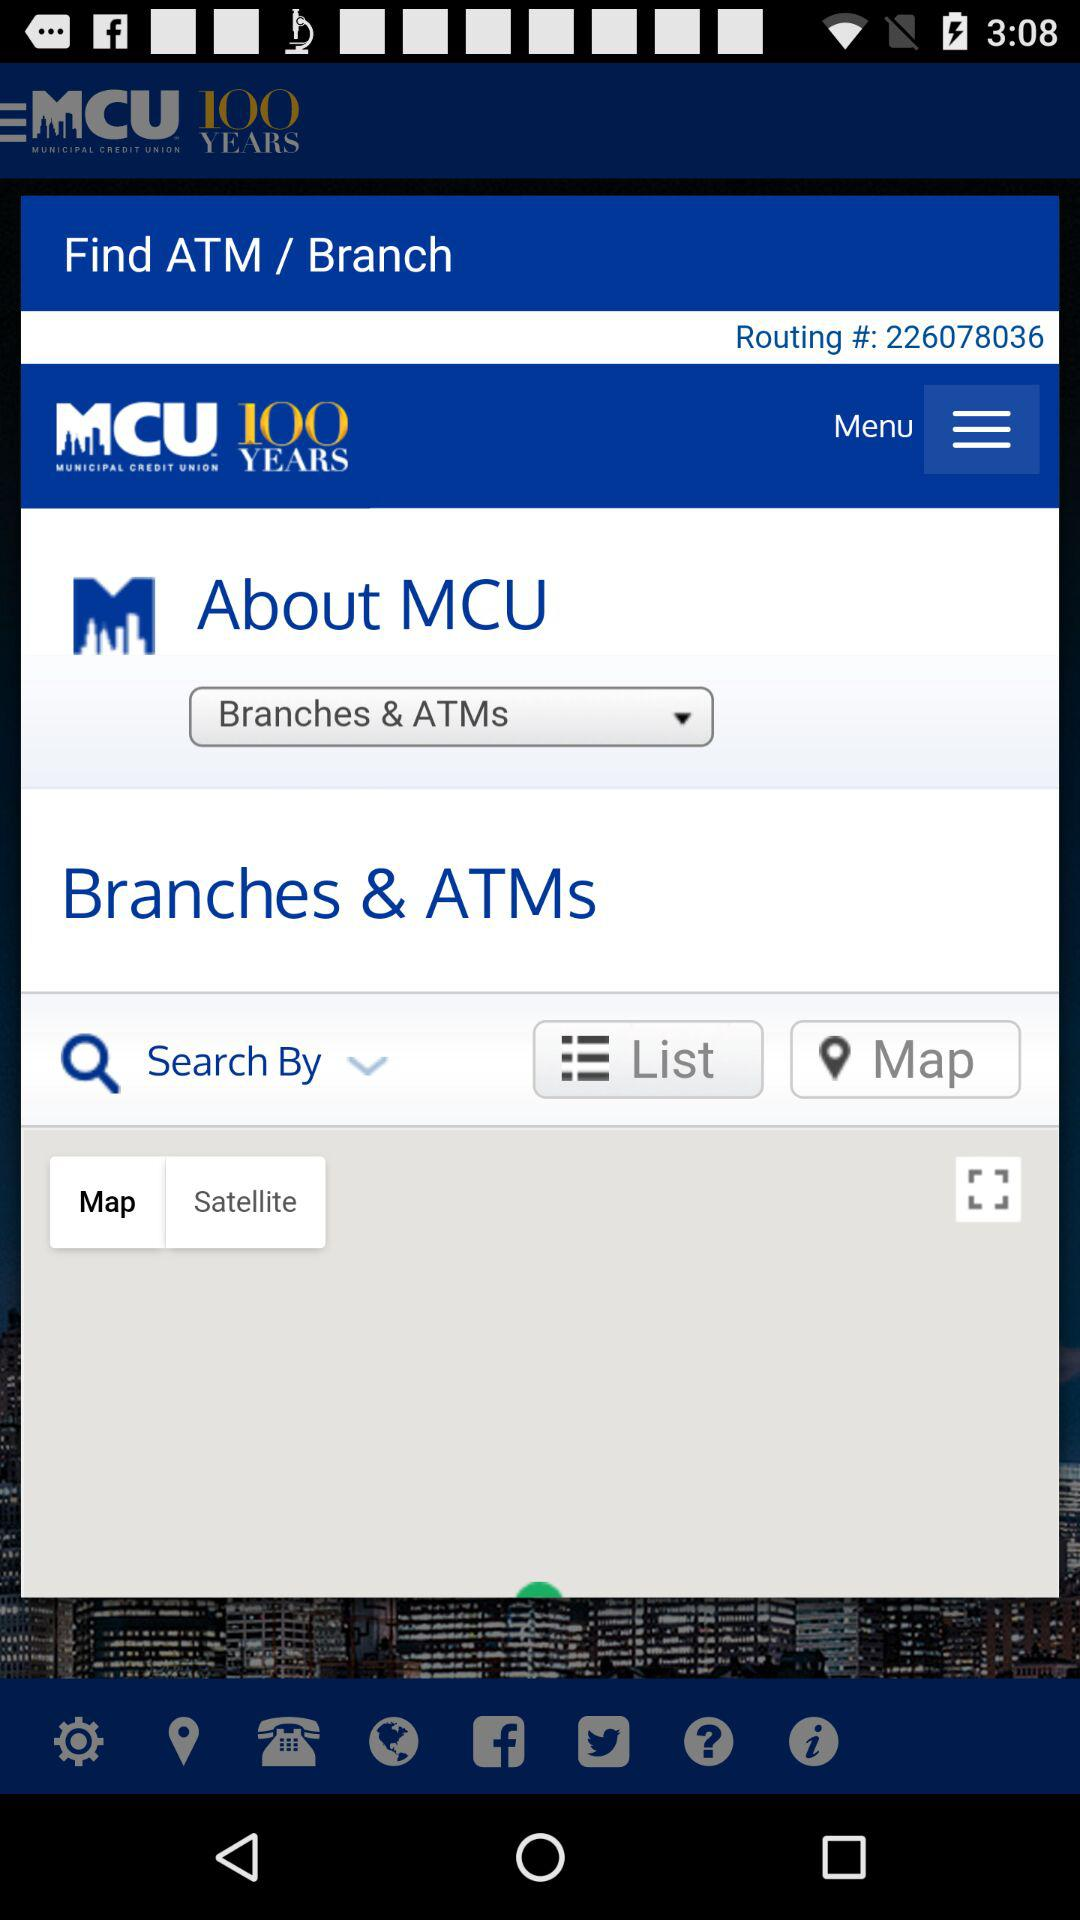Which option is selected in the "About MCU"? The selected option is "Branches & ATMs". 